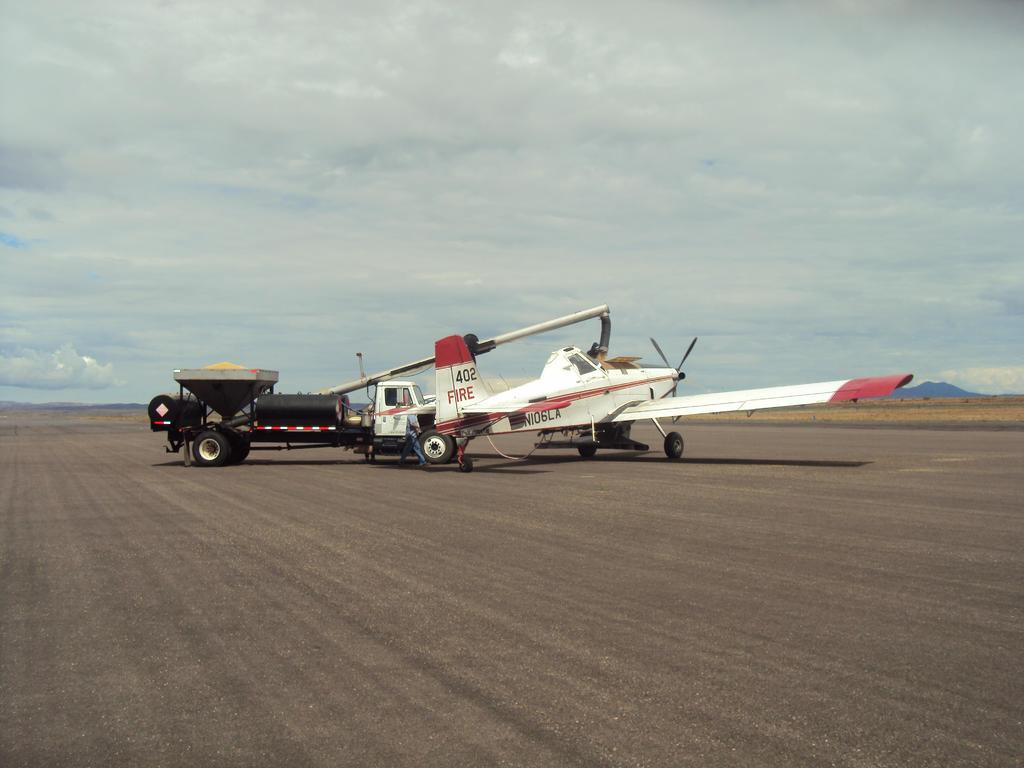What is the main subject in the middle of the image? There is a plane in the middle of the image. What else can be seen behind the plane? There is a vehicle behind the plane. What is visible in the sky at the top of the image? There are clouds visible in the sky at the top of the image. What type of event is happening with the uncle and sail in the image? There is no mention of an uncle or a sail in the image. 